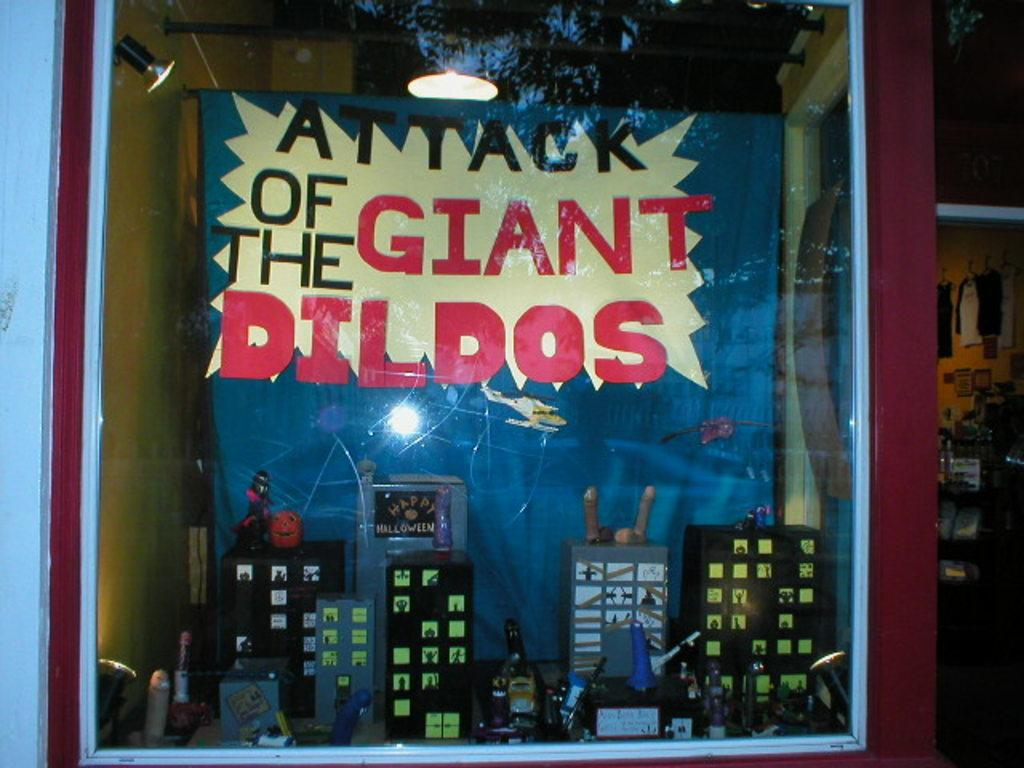<image>
Create a compact narrative representing the image presented. A cityscape in a store window has a sign that starts with the word "attack." 